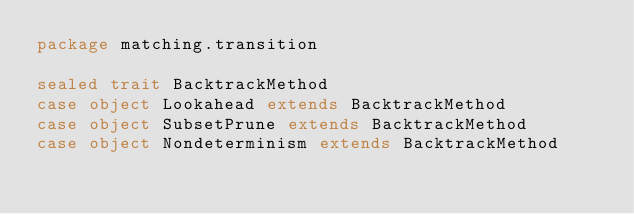<code> <loc_0><loc_0><loc_500><loc_500><_Scala_>package matching.transition

sealed trait BacktrackMethod
case object Lookahead extends BacktrackMethod
case object SubsetPrune extends BacktrackMethod
case object Nondeterminism extends BacktrackMethod
</code> 